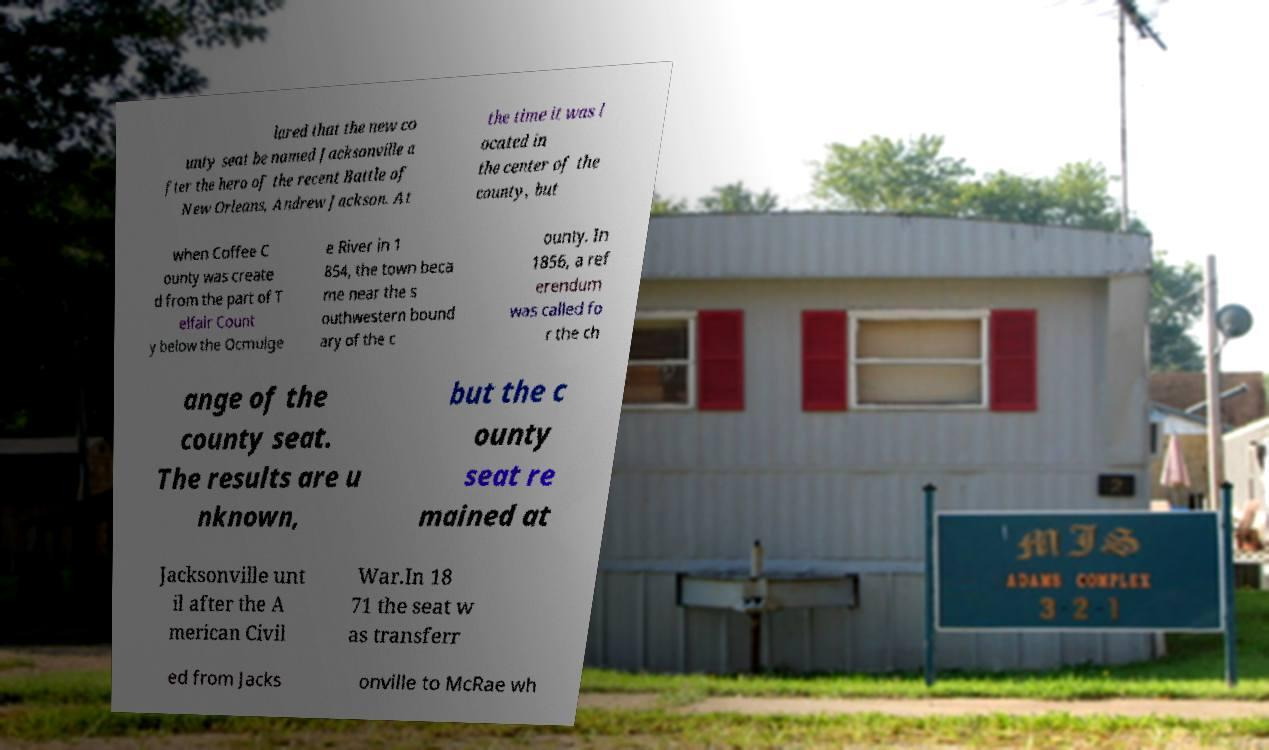Please read and relay the text visible in this image. What does it say? lared that the new co unty seat be named Jacksonville a fter the hero of the recent Battle of New Orleans, Andrew Jackson. At the time it was l ocated in the center of the county, but when Coffee C ounty was create d from the part of T elfair Count y below the Ocmulge e River in 1 854, the town beca me near the s outhwestern bound ary of the c ounty. In 1856, a ref erendum was called fo r the ch ange of the county seat. The results are u nknown, but the c ounty seat re mained at Jacksonville unt il after the A merican Civil War.In 18 71 the seat w as transferr ed from Jacks onville to McRae wh 